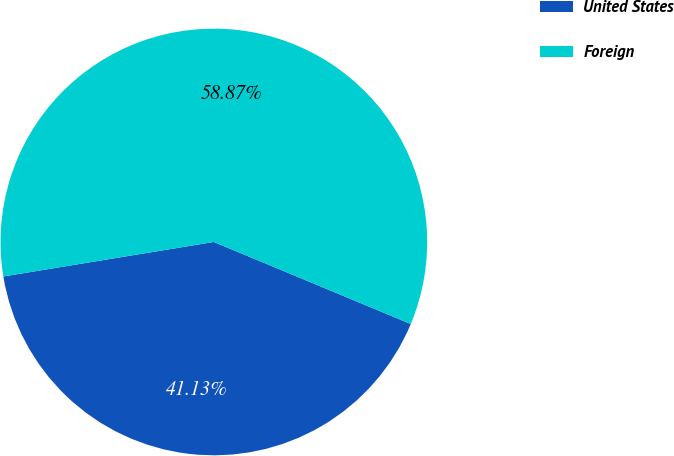Convert chart. <chart><loc_0><loc_0><loc_500><loc_500><pie_chart><fcel>United States<fcel>Foreign<nl><fcel>41.13%<fcel>58.87%<nl></chart> 